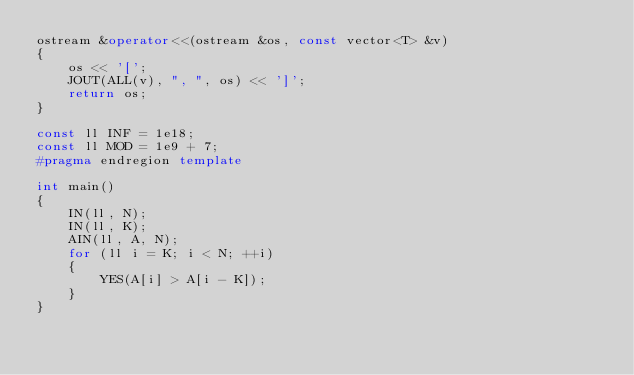Convert code to text. <code><loc_0><loc_0><loc_500><loc_500><_C++_>ostream &operator<<(ostream &os, const vector<T> &v)
{
    os << '[';
    JOUT(ALL(v), ", ", os) << ']';
    return os;
}

const ll INF = 1e18;
const ll MOD = 1e9 + 7;
#pragma endregion template

int main()
{
    IN(ll, N);
    IN(ll, K);
    AIN(ll, A, N);
    for (ll i = K; i < N; ++i)
    {
        YES(A[i] > A[i - K]);
    }
}</code> 